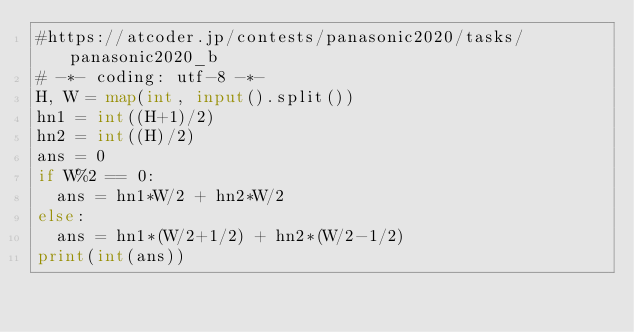Convert code to text. <code><loc_0><loc_0><loc_500><loc_500><_Python_>#https://atcoder.jp/contests/panasonic2020/tasks/panasonic2020_b
# -*- coding: utf-8 -*-
H, W = map(int, input().split())
hn1 = int((H+1)/2)
hn2 = int((H)/2)
ans = 0
if W%2 == 0:
  ans = hn1*W/2 + hn2*W/2
else:
  ans = hn1*(W/2+1/2) + hn2*(W/2-1/2)
print(int(ans))</code> 